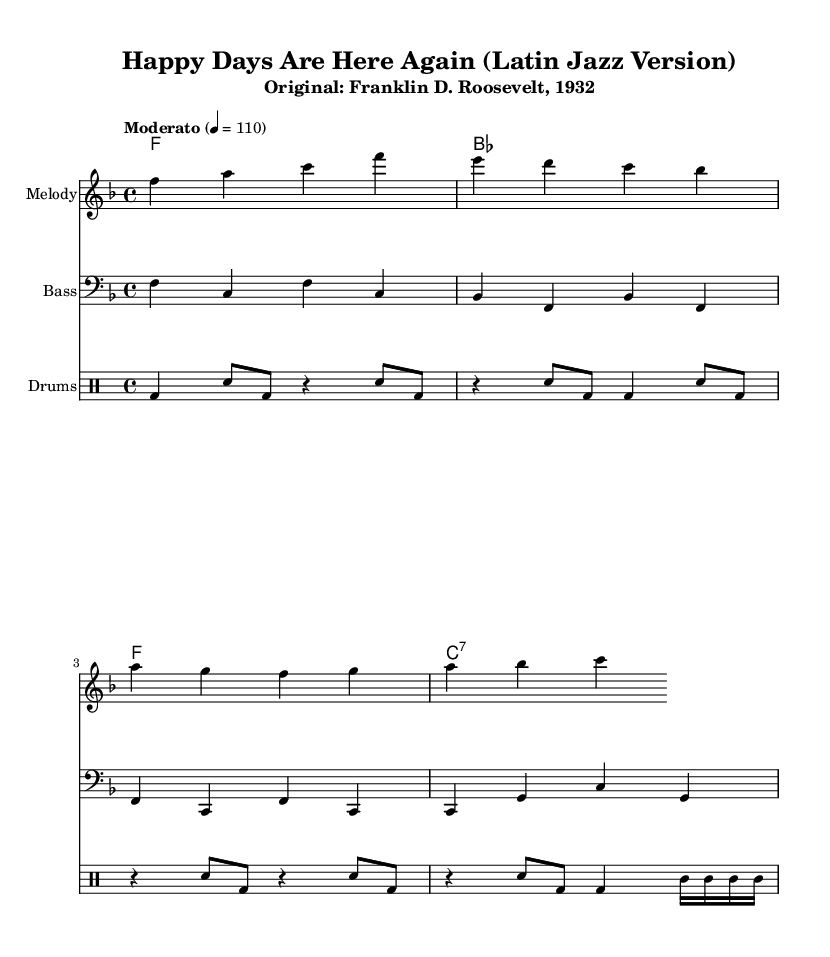What is the key signature of this music? The key signature is F major, which has one flat (B flat). This is typically indicated at the beginning of the staff before any notes are written.
Answer: F major What is the time signature of this music? The time signature is indicated right at the beginning of the score, showing the number of beats in a measure and the note value that receives one beat. Here, it shows 4/4, meaning four quarter-note beats per measure.
Answer: 4/4 What is the tempo marking for this piece? The tempo marking is written as "Moderato," which indicates a moderate speed. The numerical beat per minute (BPM) is set at 110, giving a precise guide for performers.
Answer: Moderato, 110 How many measures are there in the melody? The melody includes four measures, which can be counted by the groups of vertical lines (bar lines) separating musical phrases in the melody staff.
Answer: 4 What instrument is the melody played on? The melody is indicated to be played on a staff specifically labeled "Melody," which means it is typically played by a melodic instrument like a trumpet or saxophone.
Answer: Melody What rhythmic characteristic is common in Latin jazz, evident in the drums part? The drums part features syncopation, highlighting off-beats and creating a distinctive rhythmic feel. This is common in Latin jazz, providing a lively and engaging groove.
Answer: Syncopation What type of chords are used primarily in this score? The harmonies employed primarily consist of major chords and a seventh chord (C7), which adds a slight tension and is typical in jazz settings. This can be inferred from the chord progression provided.
Answer: Major and seventh chords 